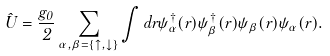Convert formula to latex. <formula><loc_0><loc_0><loc_500><loc_500>\hat { U } = \frac { g _ { 0 } } { 2 } \sum _ { \alpha , \beta = \left \{ \uparrow , \downarrow \right \} } \int d r \psi _ { \alpha } ^ { \dagger } ( r ) \psi _ { \beta } ^ { \dagger } ( r ) \psi _ { \beta } ( r ) \psi _ { \alpha } ( r ) .</formula> 